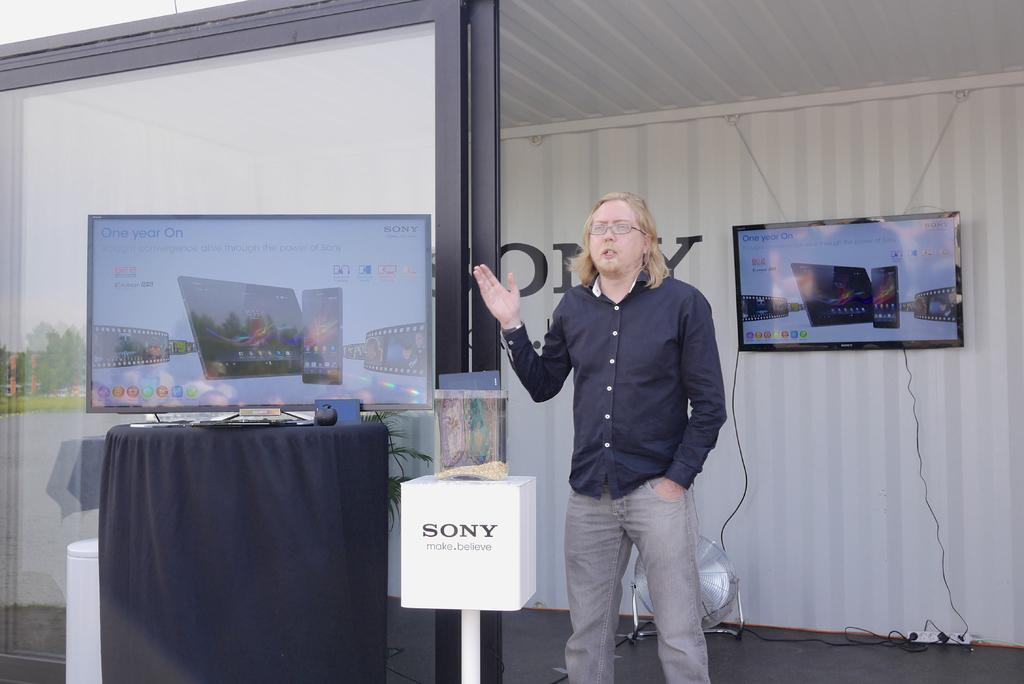Provide a one-sentence caption for the provided image. A man standing outdoors next to a Sony digitial display. 